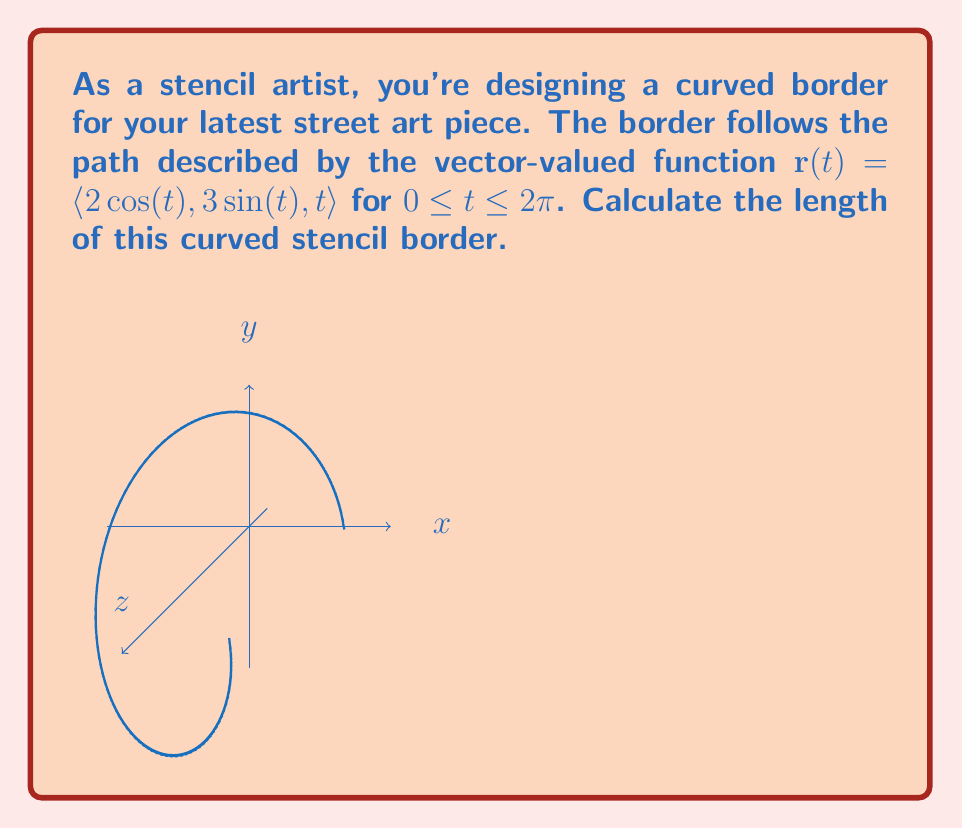Show me your answer to this math problem. To find the arc length of the curved stencil border, we'll use the arc length formula for vector-valued functions:

$L = \int_{a}^{b} |\mathbf{r}'(t)| dt$

where $\mathbf{r}'(t)$ is the derivative of the vector-valued function.

Step 1: Find $\mathbf{r}'(t)$
$\mathbf{r}'(t) = \langle -2\sin(t), 3\cos(t), 1 \rangle$

Step 2: Calculate $|\mathbf{r}'(t)|$
$|\mathbf{r}'(t)| = \sqrt{(-2\sin(t))^2 + (3\cos(t))^2 + 1^2}$
$= \sqrt{4\sin^2(t) + 9\cos^2(t) + 1}$

Step 3: Set up the integral
$L = \int_{0}^{2\pi} \sqrt{4\sin^2(t) + 9\cos^2(t) + 1} dt$

Step 4: Simplify the integrand
$4\sin^2(t) + 9\cos^2(t) + 1 = 4(1-\cos^2(t)) + 9\cos^2(t) + 1$
$= 4 - 4\cos^2(t) + 9\cos^2(t) + 1$
$= 5\cos^2(t) + 5$
$= 5(\cos^2(t) + 1)$

So, our integral becomes:
$L = \int_{0}^{2\pi} \sqrt{5(\cos^2(t) + 1)} dt$
$= \sqrt{5} \int_{0}^{2\pi} \sqrt{\cos^2(t) + 1} dt$

Step 5: This integral doesn't have an elementary antiderivative, so we need to use numerical methods or special functions to evaluate it. Using a computer algebra system, we find:

$L = \sqrt{5} \cdot 2\pi \cdot E(\frac{4}{5})$

where $E(m)$ is the complete elliptic integral of the second kind.
Answer: $L = 2\pi\sqrt{5} \cdot E(\frac{4}{5})$ 